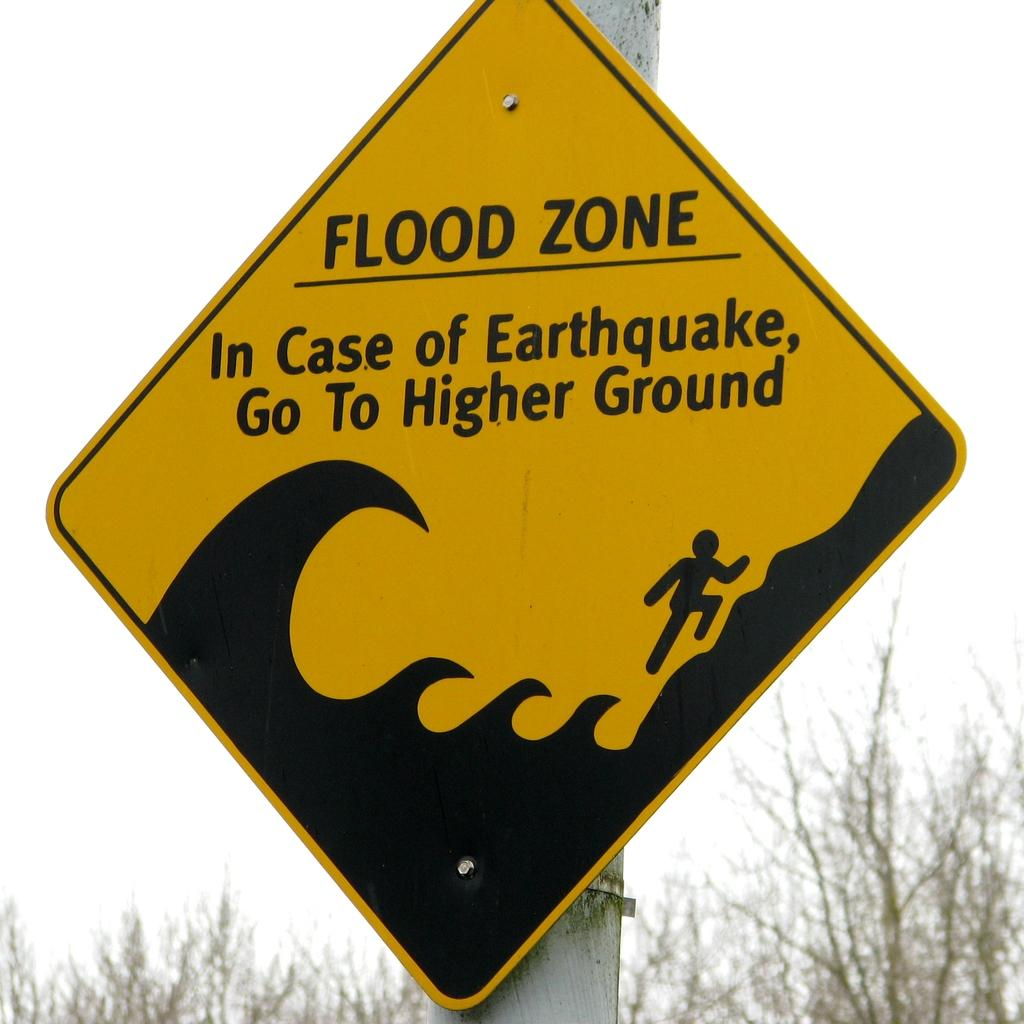<image>
Share a concise interpretation of the image provided. A yellow and black diamond shaped street sign that reads flood zone. 